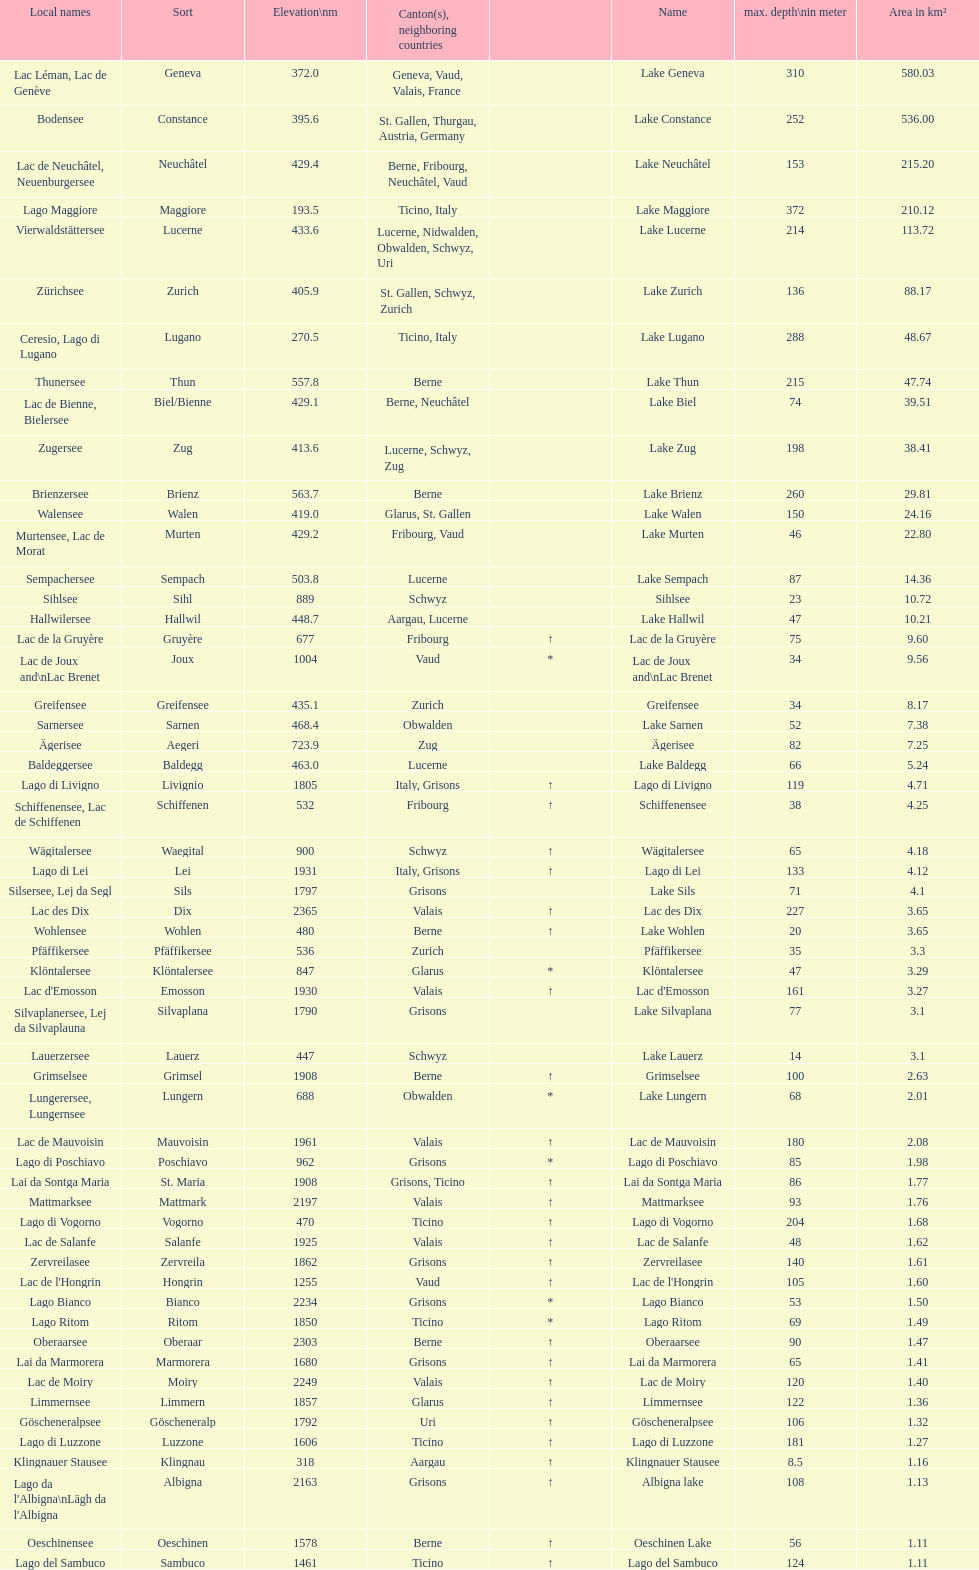Which lake has the greatest elevation? Lac des Dix. 